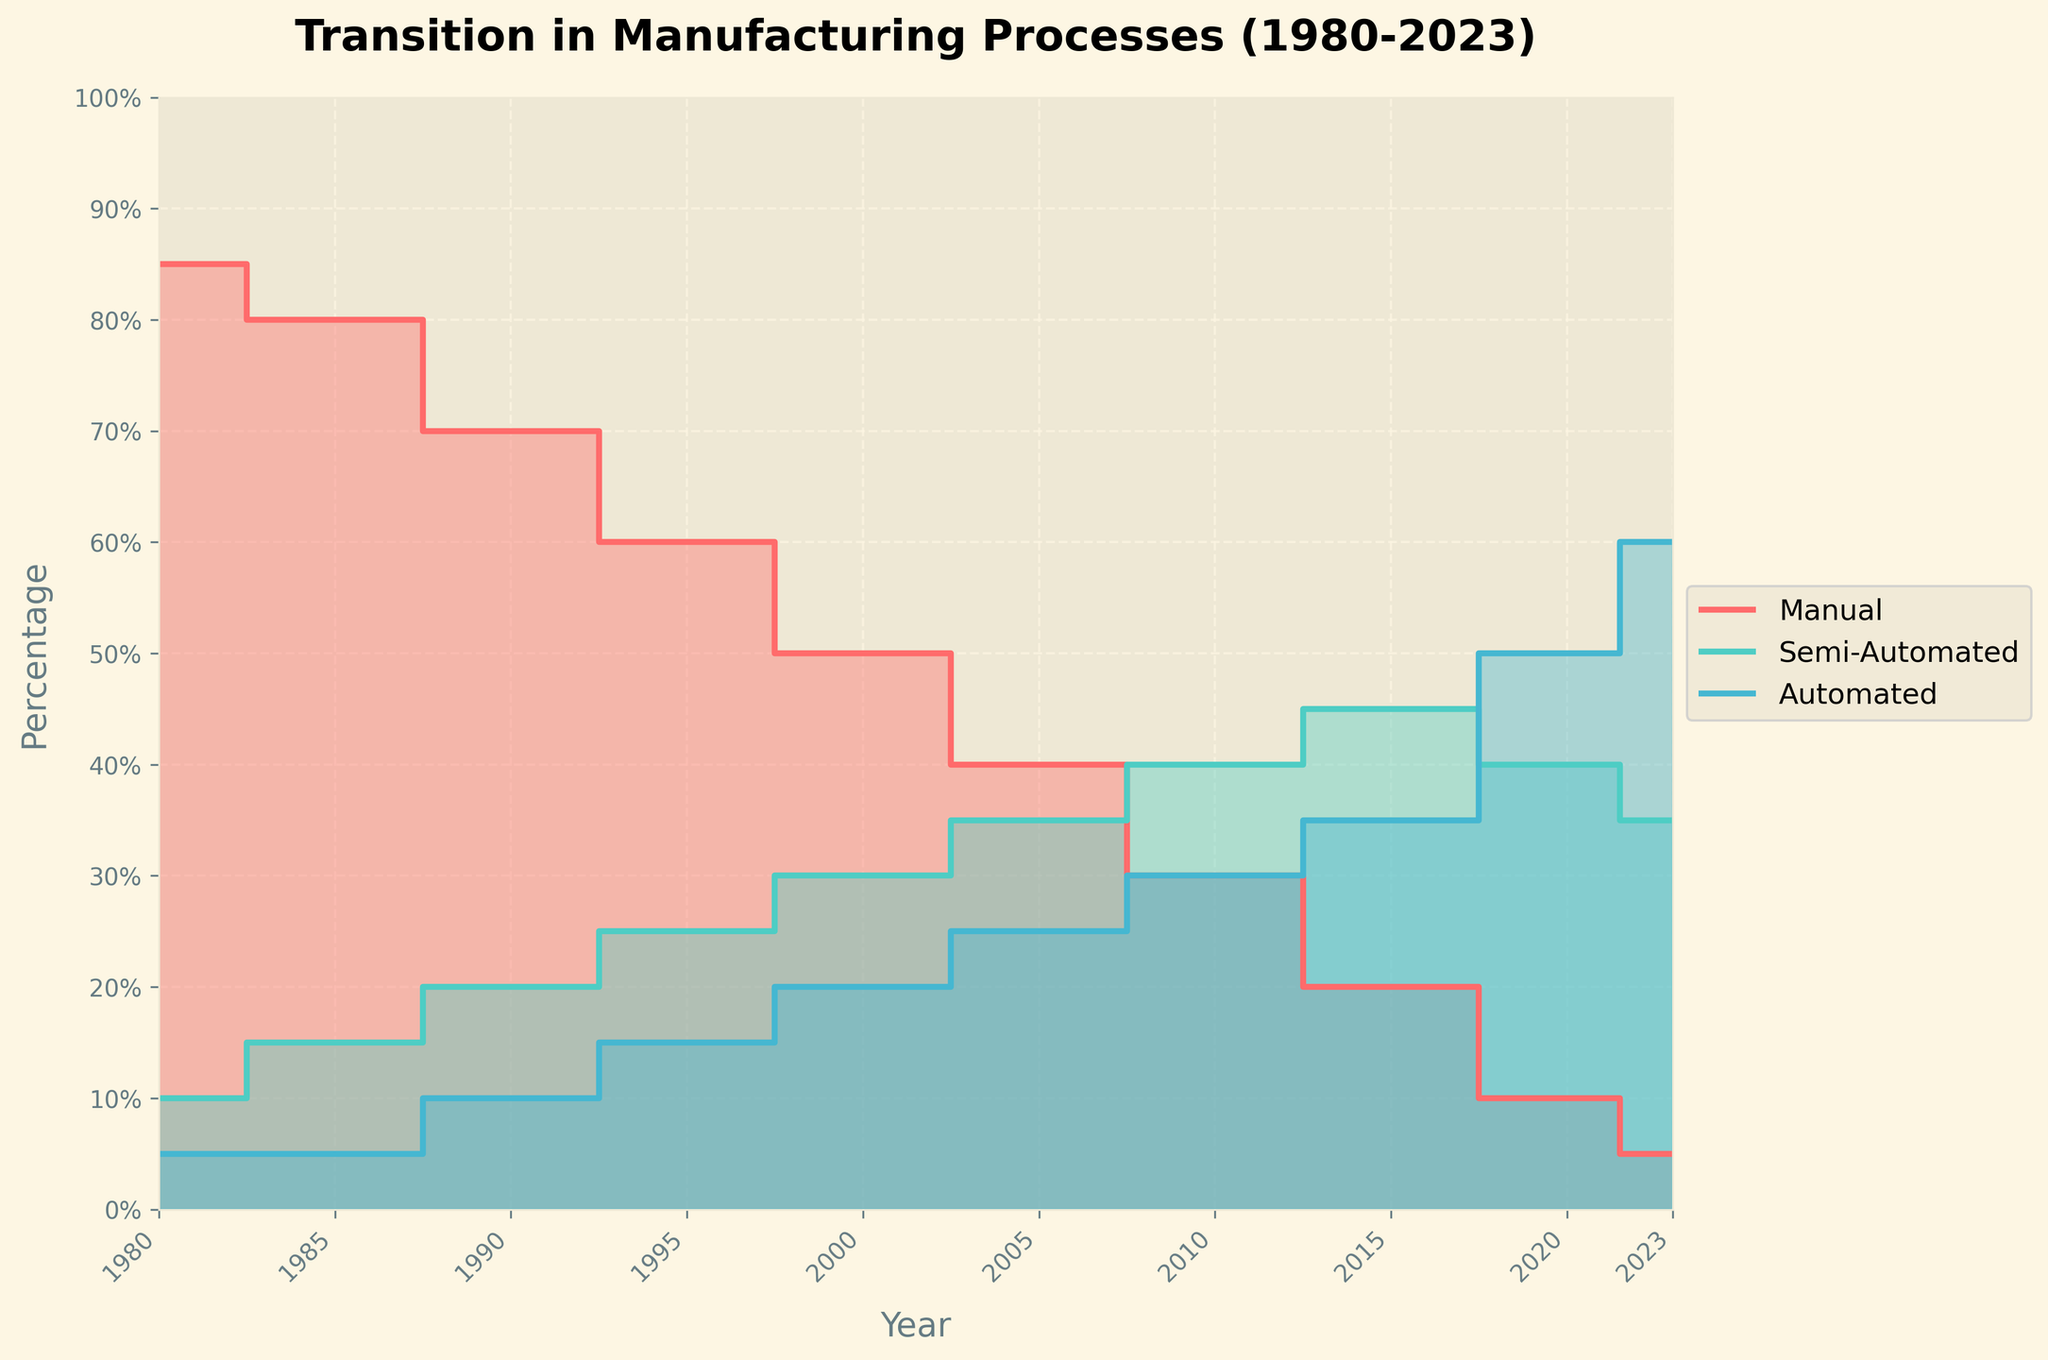What's the title of the figure? The title of the figure is displayed at the top, bolded for emphasis. It provides a summary of the visualized data.
Answer: Transition in Manufacturing Processes (1980-2023) How many distinct years are plotted on the x-axis? By counting the year labels evenly spaced along the x-axis, we can determine the number of distinct years included in the plot.
Answer: 10 Which type of processes had the highest percentage in 1990? By locating the year 1990 on the x-axis and looking at the height of each step area, we can identify that manual processes had the highest percentage.
Answer: Manual Processes What is the trend for automated processes from 1980 to 2023? By tracing the step line and the filled area representing automated processes from 1980 to 2023, we observe a continual increase over time.
Answer: Rising trend In which year did semi-automated processes reach 40%? Looking at the semi-automated process line, we find it intersects the 40% mark in the year 2010.
Answer: 2010 Between which years did manual processes see the steepest decline? Comparing the differences in manual processes' percentages between consecutive years, the steepest decline occurs between 2015 and 2020.
Answer: 2015 and 2020 Which process reached 60% in 2023? Observing the plotted data points for 2023, we see that automated processes are at 60%.
Answer: Automated Processes Compare the percentage of semi-automated processes in 2000 and 2020. By checking the semi-automated data points for the years 2000 and 2020, we see percentages of 30% and 40%, respectively, so it increased by 10%.
Answer: Increased by 10% What percentage difference is there between manual and automated processes in 1980? Observing both manual (85%) and automated (5%) process percentages in 1980, the difference is calculated as 85% - 5% = 80%.
Answer: 80% Which process had the least presence in 1985 and how did it change by 2023? In 1985, automated processes were least present at 5%. By 2023, automated processes increased to 60%.
Answer: Automated Processes, increased from 5% to 60% 